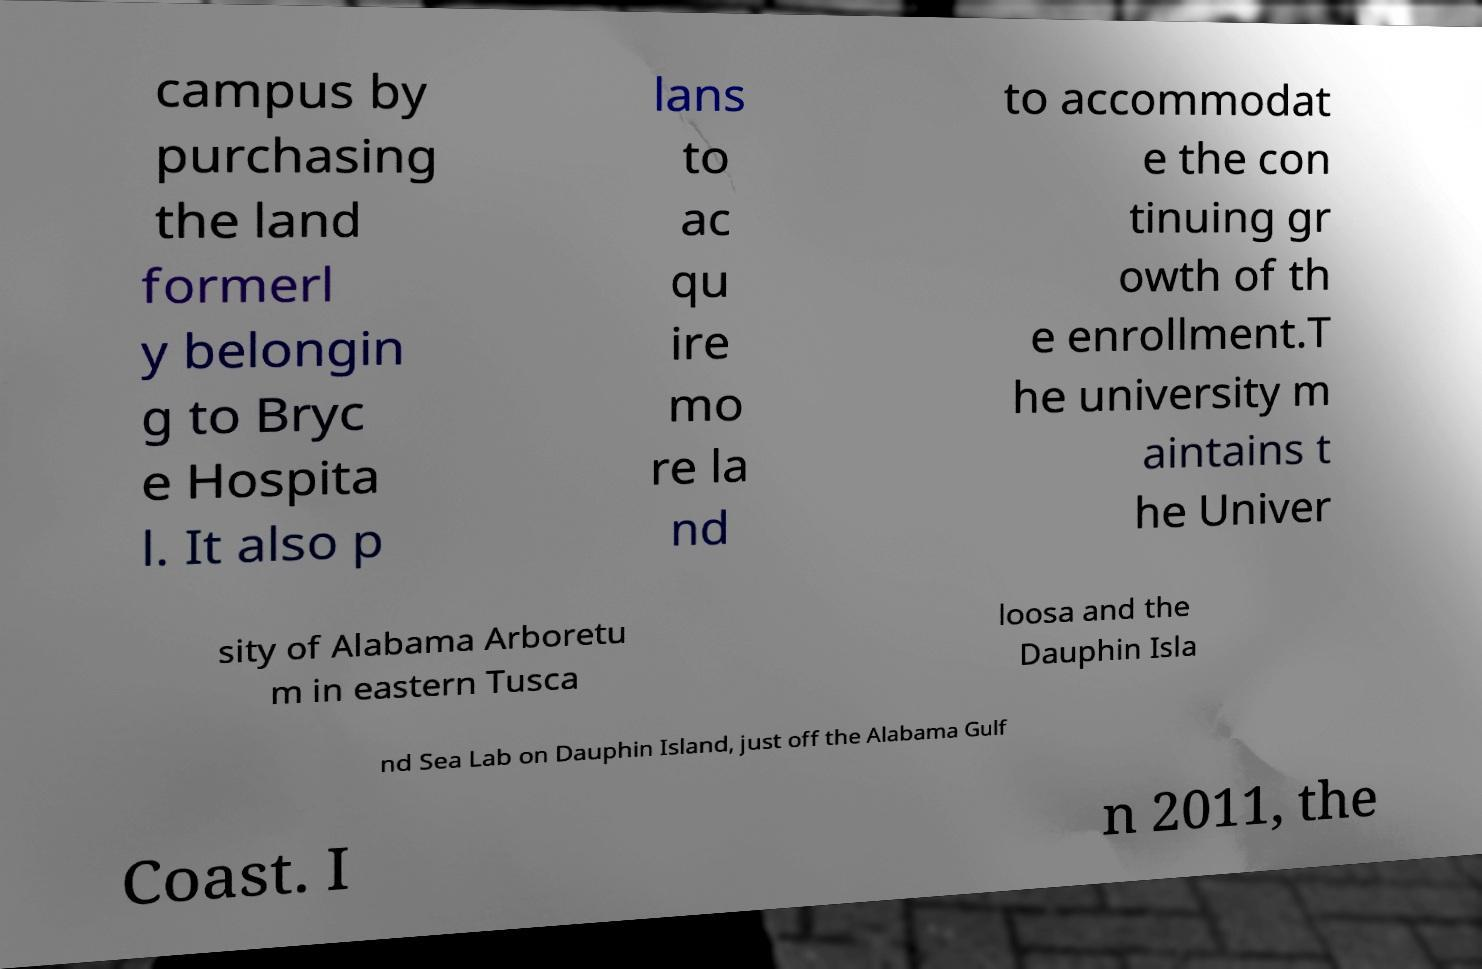Can you read and provide the text displayed in the image?This photo seems to have some interesting text. Can you extract and type it out for me? campus by purchasing the land formerl y belongin g to Bryc e Hospita l. It also p lans to ac qu ire mo re la nd to accommodat e the con tinuing gr owth of th e enrollment.T he university m aintains t he Univer sity of Alabama Arboretu m in eastern Tusca loosa and the Dauphin Isla nd Sea Lab on Dauphin Island, just off the Alabama Gulf Coast. I n 2011, the 